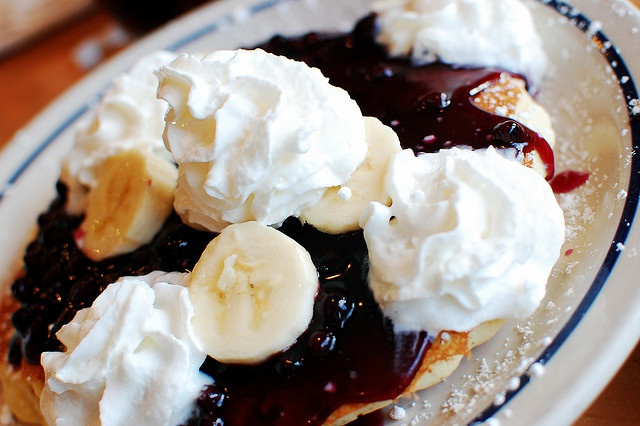Describe the objects in this image and their specific colors. I can see cake in tan, lightgray, black, and darkgray tones, banana in tan and lightgray tones, banana in tan, orange, and gray tones, and banana in tan and beige tones in this image. 